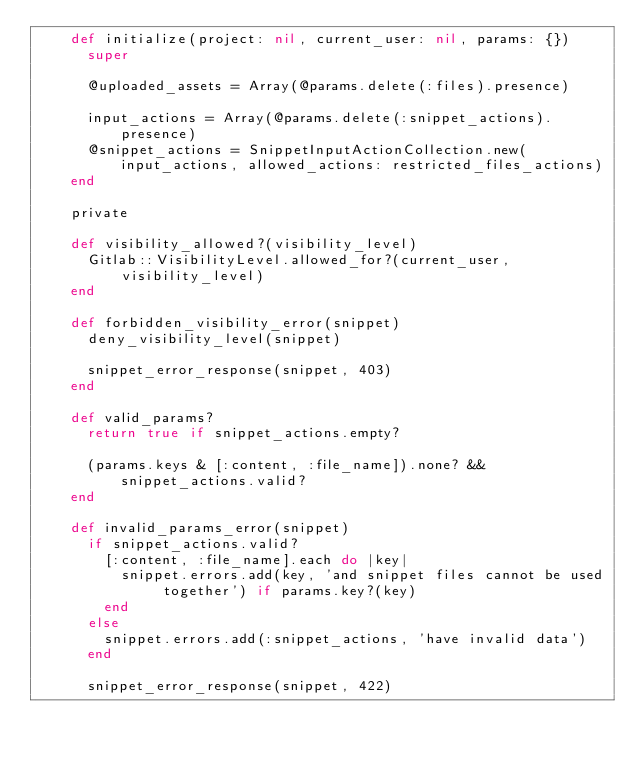<code> <loc_0><loc_0><loc_500><loc_500><_Ruby_>    def initialize(project: nil, current_user: nil, params: {})
      super

      @uploaded_assets = Array(@params.delete(:files).presence)

      input_actions = Array(@params.delete(:snippet_actions).presence)
      @snippet_actions = SnippetInputActionCollection.new(input_actions, allowed_actions: restricted_files_actions)
    end

    private

    def visibility_allowed?(visibility_level)
      Gitlab::VisibilityLevel.allowed_for?(current_user, visibility_level)
    end

    def forbidden_visibility_error(snippet)
      deny_visibility_level(snippet)

      snippet_error_response(snippet, 403)
    end

    def valid_params?
      return true if snippet_actions.empty?

      (params.keys & [:content, :file_name]).none? && snippet_actions.valid?
    end

    def invalid_params_error(snippet)
      if snippet_actions.valid?
        [:content, :file_name].each do |key|
          snippet.errors.add(key, 'and snippet files cannot be used together') if params.key?(key)
        end
      else
        snippet.errors.add(:snippet_actions, 'have invalid data')
      end

      snippet_error_response(snippet, 422)</code> 